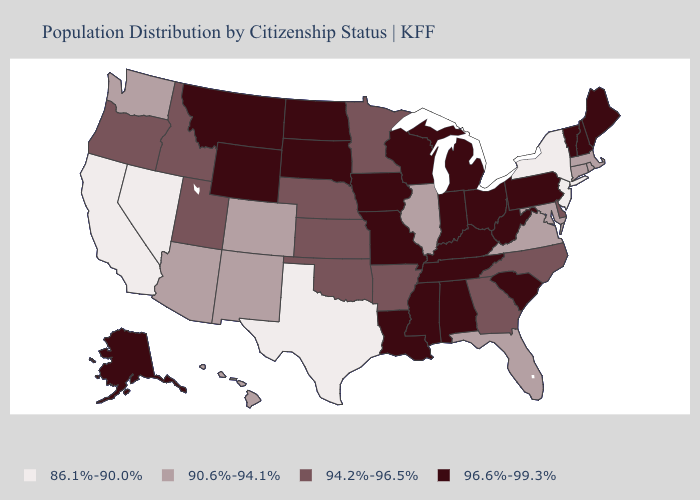Which states have the lowest value in the West?
Short answer required. California, Nevada. Does Arizona have the same value as Missouri?
Give a very brief answer. No. Among the states that border Nevada , does California have the highest value?
Write a very short answer. No. Name the states that have a value in the range 90.6%-94.1%?
Quick response, please. Arizona, Colorado, Connecticut, Florida, Hawaii, Illinois, Maryland, Massachusetts, New Mexico, Rhode Island, Virginia, Washington. Does Wisconsin have a lower value than Nebraska?
Concise answer only. No. Does Maine have the highest value in the USA?
Short answer required. Yes. What is the highest value in the West ?
Give a very brief answer. 96.6%-99.3%. What is the highest value in states that border New Jersey?
Give a very brief answer. 96.6%-99.3%. Name the states that have a value in the range 90.6%-94.1%?
Concise answer only. Arizona, Colorado, Connecticut, Florida, Hawaii, Illinois, Maryland, Massachusetts, New Mexico, Rhode Island, Virginia, Washington. Name the states that have a value in the range 96.6%-99.3%?
Concise answer only. Alabama, Alaska, Indiana, Iowa, Kentucky, Louisiana, Maine, Michigan, Mississippi, Missouri, Montana, New Hampshire, North Dakota, Ohio, Pennsylvania, South Carolina, South Dakota, Tennessee, Vermont, West Virginia, Wisconsin, Wyoming. Does Texas have the same value as Nevada?
Keep it brief. Yes. Among the states that border Vermont , does New Hampshire have the lowest value?
Keep it brief. No. What is the lowest value in the West?
Give a very brief answer. 86.1%-90.0%. Does the map have missing data?
Write a very short answer. No. What is the value of Delaware?
Be succinct. 94.2%-96.5%. 